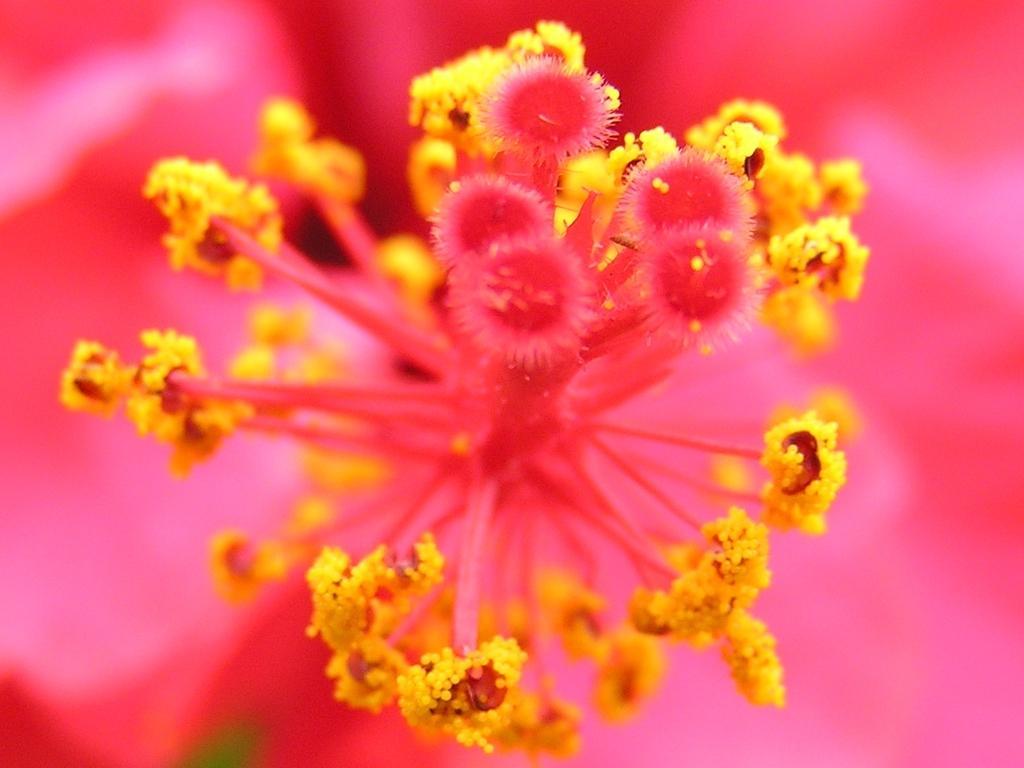Can you describe this image briefly? In this image in the foreground there is a flower, and there is a pink background. 